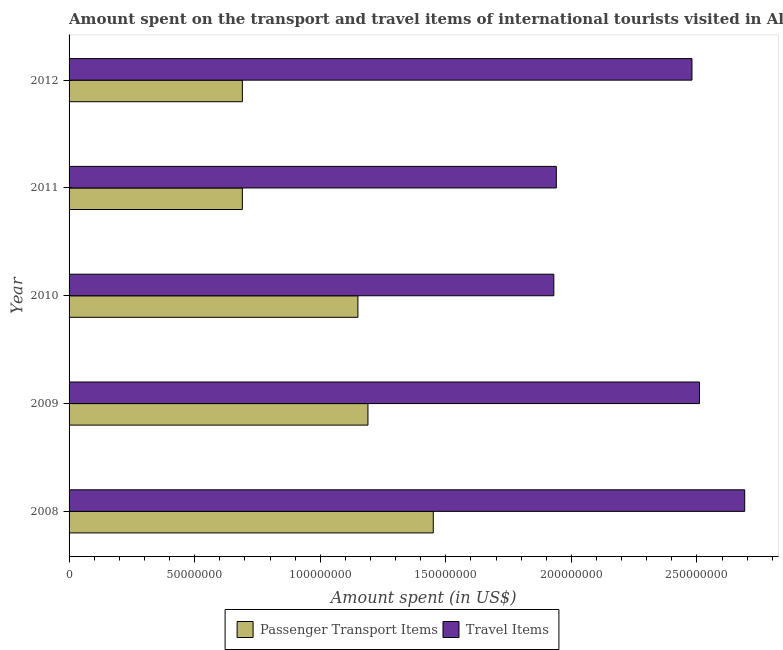Are the number of bars per tick equal to the number of legend labels?
Provide a succinct answer. Yes. How many bars are there on the 5th tick from the bottom?
Offer a very short reply. 2. What is the label of the 4th group of bars from the top?
Your answer should be very brief. 2009. What is the amount spent on passenger transport items in 2008?
Your answer should be compact. 1.45e+08. Across all years, what is the maximum amount spent in travel items?
Offer a terse response. 2.69e+08. Across all years, what is the minimum amount spent on passenger transport items?
Provide a succinct answer. 6.90e+07. In which year was the amount spent in travel items maximum?
Give a very brief answer. 2008. What is the total amount spent on passenger transport items in the graph?
Provide a short and direct response. 5.17e+08. What is the difference between the amount spent on passenger transport items in 2008 and that in 2010?
Offer a terse response. 3.00e+07. What is the difference between the amount spent on passenger transport items in 2011 and the amount spent in travel items in 2009?
Provide a short and direct response. -1.82e+08. What is the average amount spent in travel items per year?
Give a very brief answer. 2.31e+08. In the year 2011, what is the difference between the amount spent in travel items and amount spent on passenger transport items?
Give a very brief answer. 1.25e+08. In how many years, is the amount spent in travel items greater than 180000000 US$?
Ensure brevity in your answer.  5. What is the ratio of the amount spent in travel items in 2009 to that in 2010?
Offer a very short reply. 1.3. Is the amount spent in travel items in 2011 less than that in 2012?
Your response must be concise. Yes. What is the difference between the highest and the second highest amount spent in travel items?
Your response must be concise. 1.80e+07. What is the difference between the highest and the lowest amount spent on passenger transport items?
Offer a terse response. 7.60e+07. What does the 1st bar from the top in 2011 represents?
Provide a succinct answer. Travel Items. What does the 1st bar from the bottom in 2010 represents?
Give a very brief answer. Passenger Transport Items. Does the graph contain any zero values?
Make the answer very short. No. Does the graph contain grids?
Offer a very short reply. No. Where does the legend appear in the graph?
Your answer should be very brief. Bottom center. How are the legend labels stacked?
Provide a succinct answer. Horizontal. What is the title of the graph?
Keep it short and to the point. Amount spent on the transport and travel items of international tourists visited in Algeria. Does "Working only" appear as one of the legend labels in the graph?
Keep it short and to the point. No. What is the label or title of the X-axis?
Your answer should be very brief. Amount spent (in US$). What is the label or title of the Y-axis?
Your answer should be compact. Year. What is the Amount spent (in US$) of Passenger Transport Items in 2008?
Give a very brief answer. 1.45e+08. What is the Amount spent (in US$) of Travel Items in 2008?
Provide a succinct answer. 2.69e+08. What is the Amount spent (in US$) in Passenger Transport Items in 2009?
Your answer should be compact. 1.19e+08. What is the Amount spent (in US$) in Travel Items in 2009?
Provide a short and direct response. 2.51e+08. What is the Amount spent (in US$) in Passenger Transport Items in 2010?
Provide a succinct answer. 1.15e+08. What is the Amount spent (in US$) of Travel Items in 2010?
Provide a succinct answer. 1.93e+08. What is the Amount spent (in US$) of Passenger Transport Items in 2011?
Offer a terse response. 6.90e+07. What is the Amount spent (in US$) of Travel Items in 2011?
Your answer should be very brief. 1.94e+08. What is the Amount spent (in US$) of Passenger Transport Items in 2012?
Make the answer very short. 6.90e+07. What is the Amount spent (in US$) of Travel Items in 2012?
Provide a short and direct response. 2.48e+08. Across all years, what is the maximum Amount spent (in US$) in Passenger Transport Items?
Provide a short and direct response. 1.45e+08. Across all years, what is the maximum Amount spent (in US$) of Travel Items?
Provide a succinct answer. 2.69e+08. Across all years, what is the minimum Amount spent (in US$) of Passenger Transport Items?
Provide a short and direct response. 6.90e+07. Across all years, what is the minimum Amount spent (in US$) in Travel Items?
Keep it short and to the point. 1.93e+08. What is the total Amount spent (in US$) in Passenger Transport Items in the graph?
Make the answer very short. 5.17e+08. What is the total Amount spent (in US$) of Travel Items in the graph?
Offer a terse response. 1.16e+09. What is the difference between the Amount spent (in US$) in Passenger Transport Items in 2008 and that in 2009?
Your response must be concise. 2.60e+07. What is the difference between the Amount spent (in US$) of Travel Items in 2008 and that in 2009?
Your response must be concise. 1.80e+07. What is the difference between the Amount spent (in US$) of Passenger Transport Items in 2008 and that in 2010?
Ensure brevity in your answer.  3.00e+07. What is the difference between the Amount spent (in US$) of Travel Items in 2008 and that in 2010?
Your answer should be very brief. 7.60e+07. What is the difference between the Amount spent (in US$) in Passenger Transport Items in 2008 and that in 2011?
Make the answer very short. 7.60e+07. What is the difference between the Amount spent (in US$) of Travel Items in 2008 and that in 2011?
Provide a succinct answer. 7.50e+07. What is the difference between the Amount spent (in US$) in Passenger Transport Items in 2008 and that in 2012?
Keep it short and to the point. 7.60e+07. What is the difference between the Amount spent (in US$) in Travel Items in 2008 and that in 2012?
Your answer should be very brief. 2.10e+07. What is the difference between the Amount spent (in US$) in Passenger Transport Items in 2009 and that in 2010?
Your answer should be compact. 4.00e+06. What is the difference between the Amount spent (in US$) of Travel Items in 2009 and that in 2010?
Your response must be concise. 5.80e+07. What is the difference between the Amount spent (in US$) in Travel Items in 2009 and that in 2011?
Make the answer very short. 5.70e+07. What is the difference between the Amount spent (in US$) in Passenger Transport Items in 2010 and that in 2011?
Ensure brevity in your answer.  4.60e+07. What is the difference between the Amount spent (in US$) of Travel Items in 2010 and that in 2011?
Offer a very short reply. -1.00e+06. What is the difference between the Amount spent (in US$) of Passenger Transport Items in 2010 and that in 2012?
Ensure brevity in your answer.  4.60e+07. What is the difference between the Amount spent (in US$) in Travel Items in 2010 and that in 2012?
Your response must be concise. -5.50e+07. What is the difference between the Amount spent (in US$) in Passenger Transport Items in 2011 and that in 2012?
Ensure brevity in your answer.  0. What is the difference between the Amount spent (in US$) of Travel Items in 2011 and that in 2012?
Give a very brief answer. -5.40e+07. What is the difference between the Amount spent (in US$) in Passenger Transport Items in 2008 and the Amount spent (in US$) in Travel Items in 2009?
Provide a succinct answer. -1.06e+08. What is the difference between the Amount spent (in US$) in Passenger Transport Items in 2008 and the Amount spent (in US$) in Travel Items in 2010?
Make the answer very short. -4.80e+07. What is the difference between the Amount spent (in US$) in Passenger Transport Items in 2008 and the Amount spent (in US$) in Travel Items in 2011?
Provide a succinct answer. -4.90e+07. What is the difference between the Amount spent (in US$) of Passenger Transport Items in 2008 and the Amount spent (in US$) of Travel Items in 2012?
Provide a short and direct response. -1.03e+08. What is the difference between the Amount spent (in US$) of Passenger Transport Items in 2009 and the Amount spent (in US$) of Travel Items in 2010?
Provide a succinct answer. -7.40e+07. What is the difference between the Amount spent (in US$) in Passenger Transport Items in 2009 and the Amount spent (in US$) in Travel Items in 2011?
Make the answer very short. -7.50e+07. What is the difference between the Amount spent (in US$) in Passenger Transport Items in 2009 and the Amount spent (in US$) in Travel Items in 2012?
Give a very brief answer. -1.29e+08. What is the difference between the Amount spent (in US$) in Passenger Transport Items in 2010 and the Amount spent (in US$) in Travel Items in 2011?
Your answer should be compact. -7.90e+07. What is the difference between the Amount spent (in US$) of Passenger Transport Items in 2010 and the Amount spent (in US$) of Travel Items in 2012?
Provide a short and direct response. -1.33e+08. What is the difference between the Amount spent (in US$) of Passenger Transport Items in 2011 and the Amount spent (in US$) of Travel Items in 2012?
Provide a short and direct response. -1.79e+08. What is the average Amount spent (in US$) in Passenger Transport Items per year?
Keep it short and to the point. 1.03e+08. What is the average Amount spent (in US$) in Travel Items per year?
Provide a short and direct response. 2.31e+08. In the year 2008, what is the difference between the Amount spent (in US$) of Passenger Transport Items and Amount spent (in US$) of Travel Items?
Make the answer very short. -1.24e+08. In the year 2009, what is the difference between the Amount spent (in US$) of Passenger Transport Items and Amount spent (in US$) of Travel Items?
Your answer should be very brief. -1.32e+08. In the year 2010, what is the difference between the Amount spent (in US$) in Passenger Transport Items and Amount spent (in US$) in Travel Items?
Your answer should be compact. -7.80e+07. In the year 2011, what is the difference between the Amount spent (in US$) in Passenger Transport Items and Amount spent (in US$) in Travel Items?
Keep it short and to the point. -1.25e+08. In the year 2012, what is the difference between the Amount spent (in US$) in Passenger Transport Items and Amount spent (in US$) in Travel Items?
Provide a succinct answer. -1.79e+08. What is the ratio of the Amount spent (in US$) of Passenger Transport Items in 2008 to that in 2009?
Your response must be concise. 1.22. What is the ratio of the Amount spent (in US$) in Travel Items in 2008 to that in 2009?
Make the answer very short. 1.07. What is the ratio of the Amount spent (in US$) in Passenger Transport Items in 2008 to that in 2010?
Your answer should be compact. 1.26. What is the ratio of the Amount spent (in US$) in Travel Items in 2008 to that in 2010?
Your answer should be compact. 1.39. What is the ratio of the Amount spent (in US$) in Passenger Transport Items in 2008 to that in 2011?
Offer a very short reply. 2.1. What is the ratio of the Amount spent (in US$) of Travel Items in 2008 to that in 2011?
Make the answer very short. 1.39. What is the ratio of the Amount spent (in US$) of Passenger Transport Items in 2008 to that in 2012?
Your answer should be very brief. 2.1. What is the ratio of the Amount spent (in US$) of Travel Items in 2008 to that in 2012?
Give a very brief answer. 1.08. What is the ratio of the Amount spent (in US$) of Passenger Transport Items in 2009 to that in 2010?
Keep it short and to the point. 1.03. What is the ratio of the Amount spent (in US$) in Travel Items in 2009 to that in 2010?
Ensure brevity in your answer.  1.3. What is the ratio of the Amount spent (in US$) of Passenger Transport Items in 2009 to that in 2011?
Keep it short and to the point. 1.72. What is the ratio of the Amount spent (in US$) in Travel Items in 2009 to that in 2011?
Make the answer very short. 1.29. What is the ratio of the Amount spent (in US$) in Passenger Transport Items in 2009 to that in 2012?
Offer a terse response. 1.72. What is the ratio of the Amount spent (in US$) of Travel Items in 2009 to that in 2012?
Your answer should be compact. 1.01. What is the ratio of the Amount spent (in US$) in Passenger Transport Items in 2010 to that in 2012?
Keep it short and to the point. 1.67. What is the ratio of the Amount spent (in US$) in Travel Items in 2010 to that in 2012?
Your response must be concise. 0.78. What is the ratio of the Amount spent (in US$) in Passenger Transport Items in 2011 to that in 2012?
Provide a succinct answer. 1. What is the ratio of the Amount spent (in US$) of Travel Items in 2011 to that in 2012?
Your answer should be very brief. 0.78. What is the difference between the highest and the second highest Amount spent (in US$) of Passenger Transport Items?
Make the answer very short. 2.60e+07. What is the difference between the highest and the second highest Amount spent (in US$) in Travel Items?
Make the answer very short. 1.80e+07. What is the difference between the highest and the lowest Amount spent (in US$) in Passenger Transport Items?
Your answer should be very brief. 7.60e+07. What is the difference between the highest and the lowest Amount spent (in US$) of Travel Items?
Provide a succinct answer. 7.60e+07. 